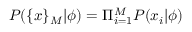<formula> <loc_0><loc_0><loc_500><loc_500>P ( \{ x \} _ { M } | \phi ) = \Pi _ { i = 1 } ^ { M } P ( x _ { i } | \phi )</formula> 